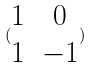Convert formula to latex. <formula><loc_0><loc_0><loc_500><loc_500>( \begin{matrix} 1 & 0 \\ 1 & - 1 \end{matrix} )</formula> 